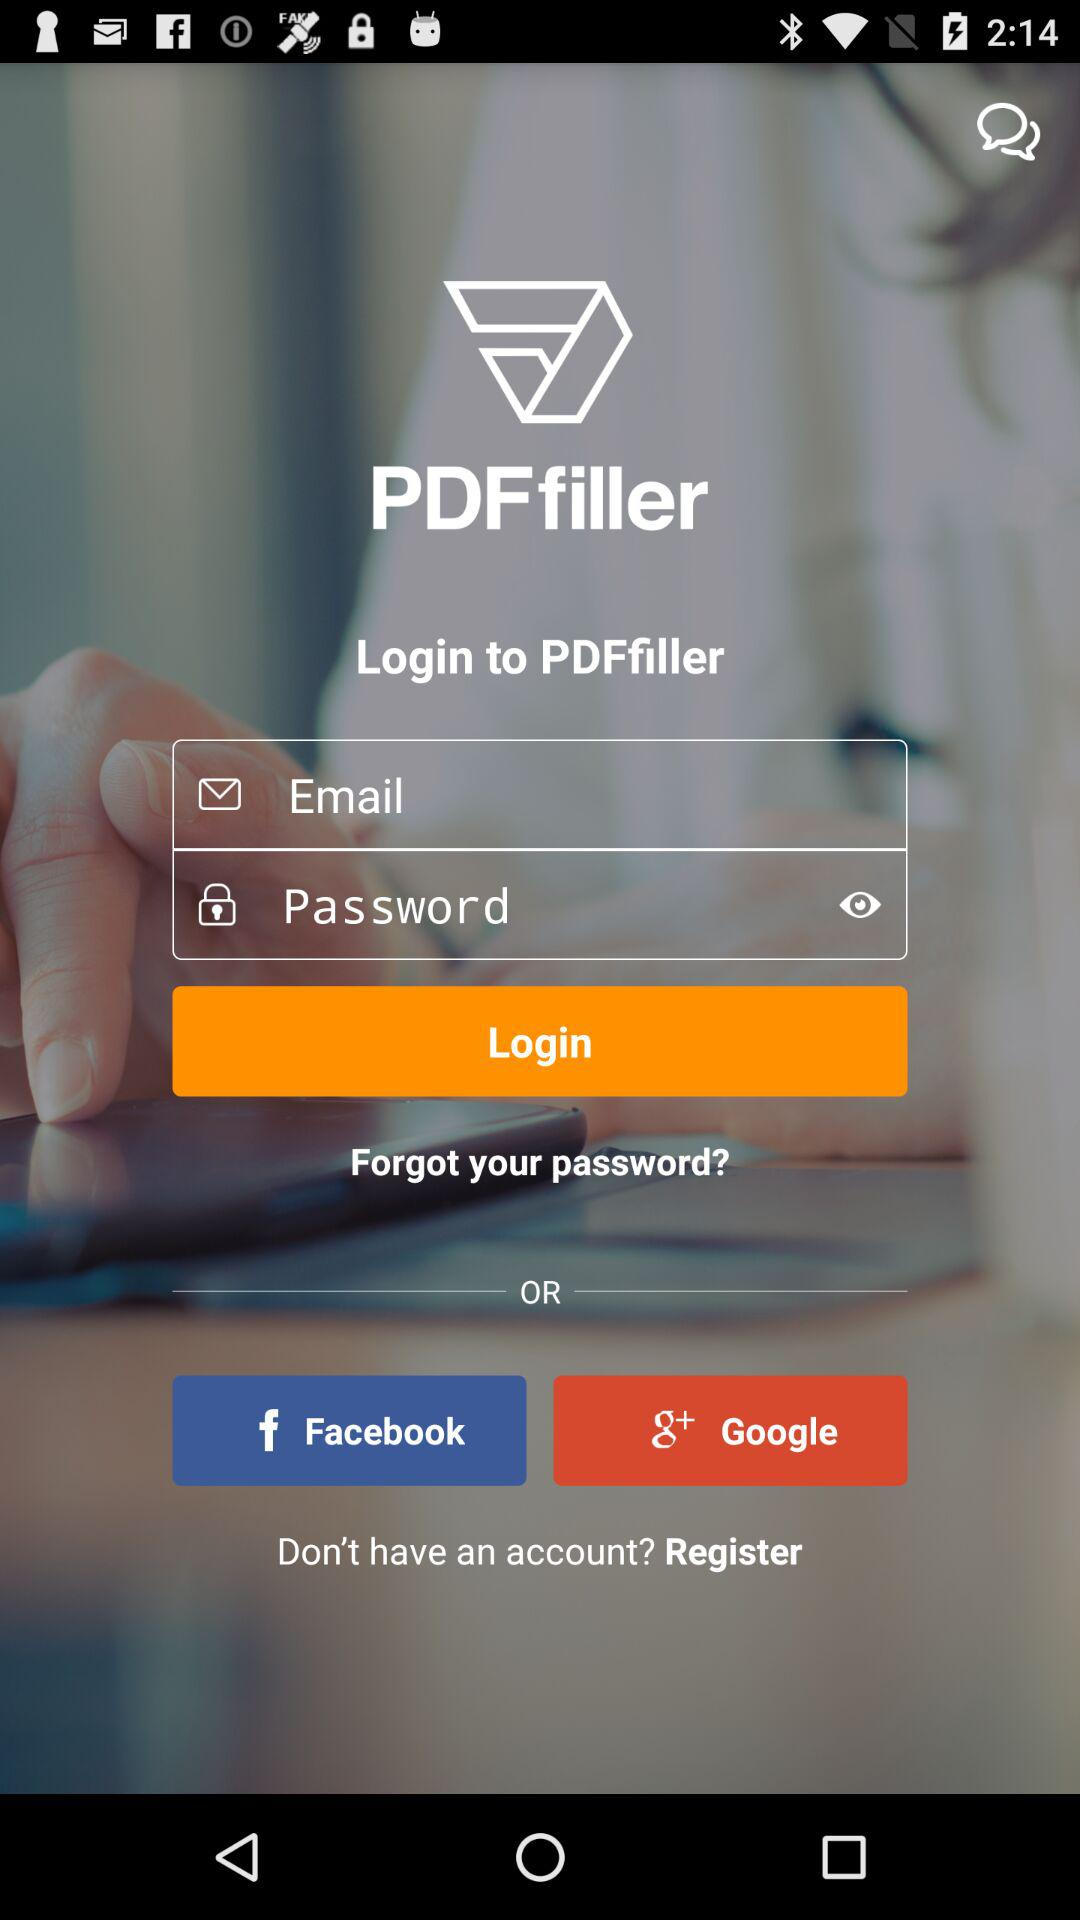What is the application name? The application name is "PDFfiller". 